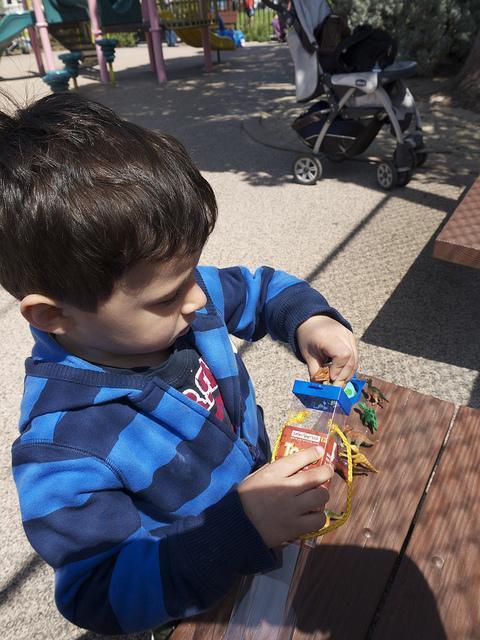How many women are in the picture?
Give a very brief answer. 0. How many benches are in the photo?
Give a very brief answer. 2. 